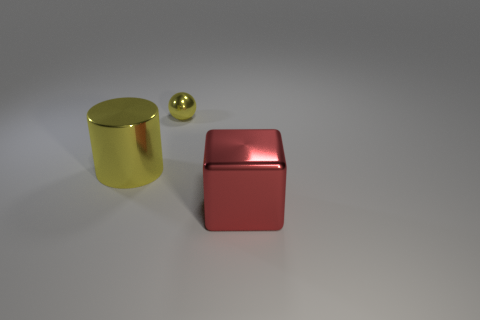The red metal thing is what shape?
Offer a terse response. Cube. There is a thing on the right side of the yellow shiny thing right of the large yellow cylinder; how big is it?
Your answer should be very brief. Large. What number of objects are big yellow cylinders or red matte things?
Provide a succinct answer. 1. Is the big yellow shiny thing the same shape as the small yellow metallic thing?
Your answer should be very brief. No. Is there a big red cube that has the same material as the tiny yellow sphere?
Your answer should be very brief. Yes. There is a shiny object that is behind the large yellow metallic cylinder; are there any large red cubes on the right side of it?
Make the answer very short. Yes. Is the size of the shiny thing behind the cylinder the same as the metal cube?
Your response must be concise. No. The sphere has what size?
Offer a terse response. Small. Is there a ball that has the same color as the big shiny cylinder?
Keep it short and to the point. Yes. What number of big things are either yellow things or red cubes?
Your answer should be very brief. 2. 